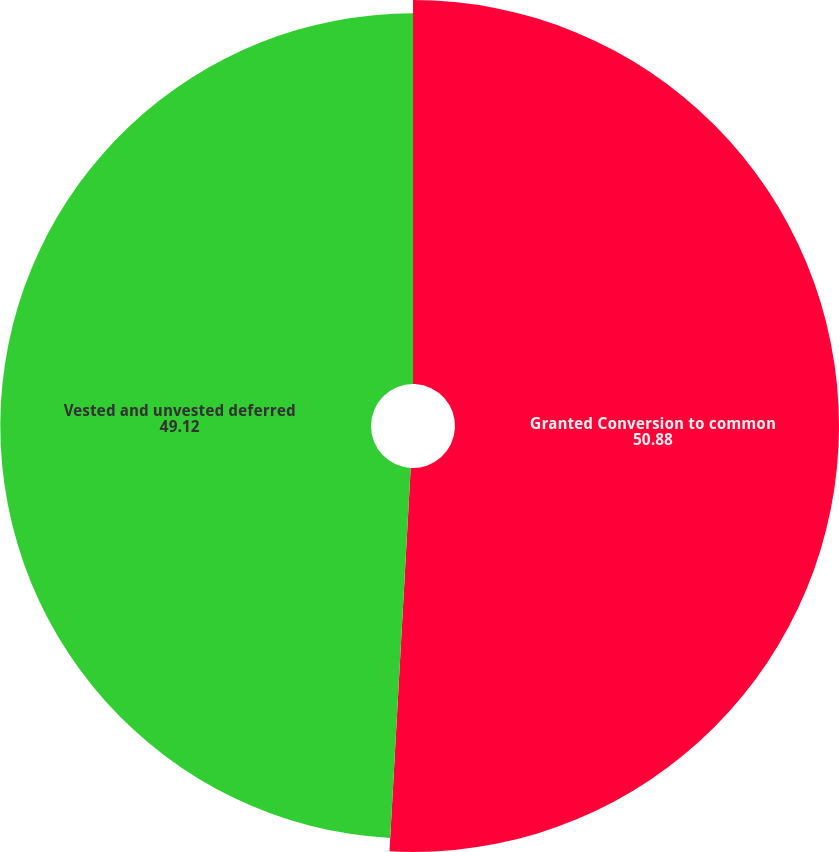Convert chart. <chart><loc_0><loc_0><loc_500><loc_500><pie_chart><fcel>Granted Conversion to common<fcel>Vested and unvested deferred<nl><fcel>50.88%<fcel>49.12%<nl></chart> 